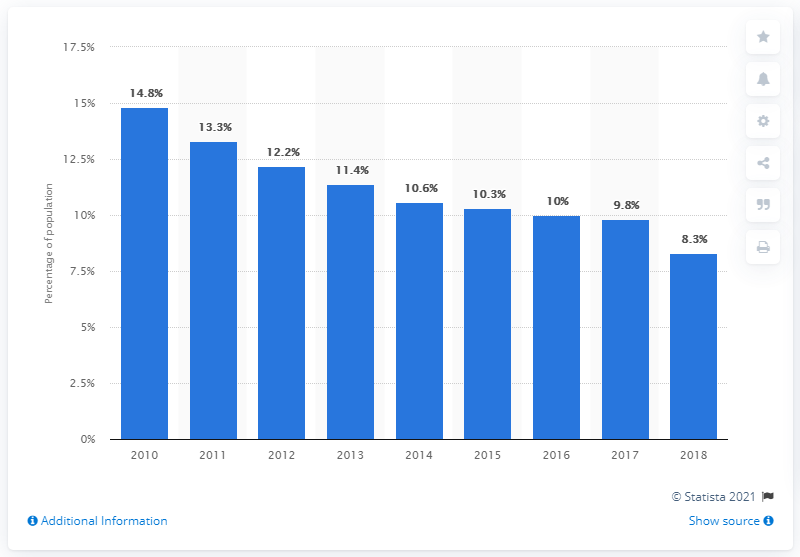Draw attention to some important aspects in this diagram. In 2018, approximately 8.3% of the Peruvian population lived on less than 3.20 U.S. dollars per day, according to recent data. 